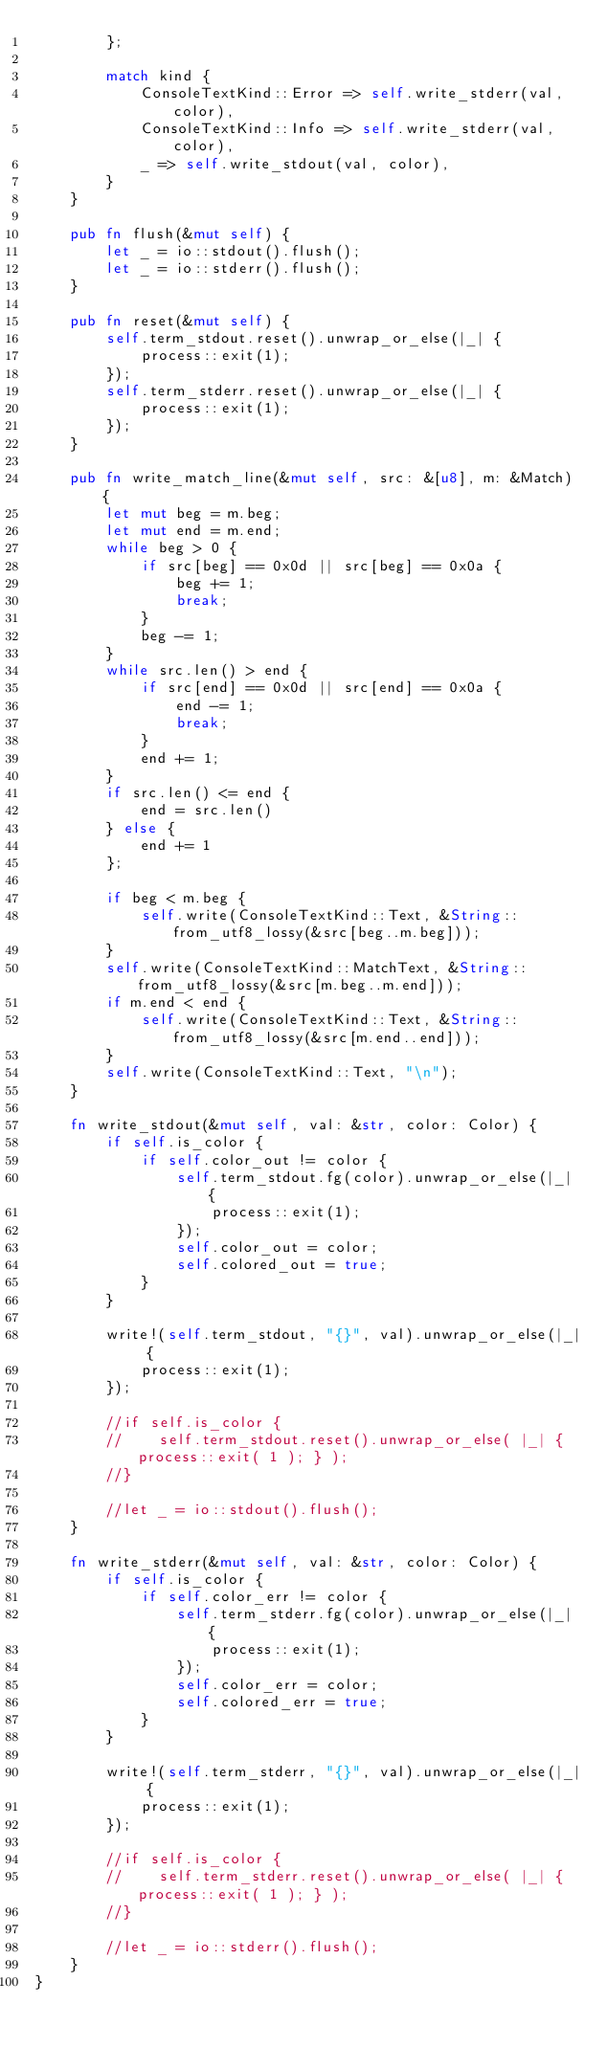Convert code to text. <code><loc_0><loc_0><loc_500><loc_500><_Rust_>        };

        match kind {
            ConsoleTextKind::Error => self.write_stderr(val, color),
            ConsoleTextKind::Info => self.write_stderr(val, color),
            _ => self.write_stdout(val, color),
        }
    }

    pub fn flush(&mut self) {
        let _ = io::stdout().flush();
        let _ = io::stderr().flush();
    }

    pub fn reset(&mut self) {
        self.term_stdout.reset().unwrap_or_else(|_| {
            process::exit(1);
        });
        self.term_stderr.reset().unwrap_or_else(|_| {
            process::exit(1);
        });
    }

    pub fn write_match_line(&mut self, src: &[u8], m: &Match) {
        let mut beg = m.beg;
        let mut end = m.end;
        while beg > 0 {
            if src[beg] == 0x0d || src[beg] == 0x0a {
                beg += 1;
                break;
            }
            beg -= 1;
        }
        while src.len() > end {
            if src[end] == 0x0d || src[end] == 0x0a {
                end -= 1;
                break;
            }
            end += 1;
        }
        if src.len() <= end {
            end = src.len()
        } else {
            end += 1
        };

        if beg < m.beg {
            self.write(ConsoleTextKind::Text, &String::from_utf8_lossy(&src[beg..m.beg]));
        }
        self.write(ConsoleTextKind::MatchText, &String::from_utf8_lossy(&src[m.beg..m.end]));
        if m.end < end {
            self.write(ConsoleTextKind::Text, &String::from_utf8_lossy(&src[m.end..end]));
        }
        self.write(ConsoleTextKind::Text, "\n");
    }

    fn write_stdout(&mut self, val: &str, color: Color) {
        if self.is_color {
            if self.color_out != color {
                self.term_stdout.fg(color).unwrap_or_else(|_| {
                    process::exit(1);
                });
                self.color_out = color;
                self.colored_out = true;
            }
        }

        write!(self.term_stdout, "{}", val).unwrap_or_else(|_| {
            process::exit(1);
        });

        //if self.is_color {
        //    self.term_stdout.reset().unwrap_or_else( |_| { process::exit( 1 ); } );
        //}

        //let _ = io::stdout().flush();
    }

    fn write_stderr(&mut self, val: &str, color: Color) {
        if self.is_color {
            if self.color_err != color {
                self.term_stderr.fg(color).unwrap_or_else(|_| {
                    process::exit(1);
                });
                self.color_err = color;
                self.colored_err = true;
            }
        }

        write!(self.term_stderr, "{}", val).unwrap_or_else(|_| {
            process::exit(1);
        });

        //if self.is_color {
        //    self.term_stderr.reset().unwrap_or_else( |_| { process::exit( 1 ); } );
        //}

        //let _ = io::stderr().flush();
    }
}
</code> 